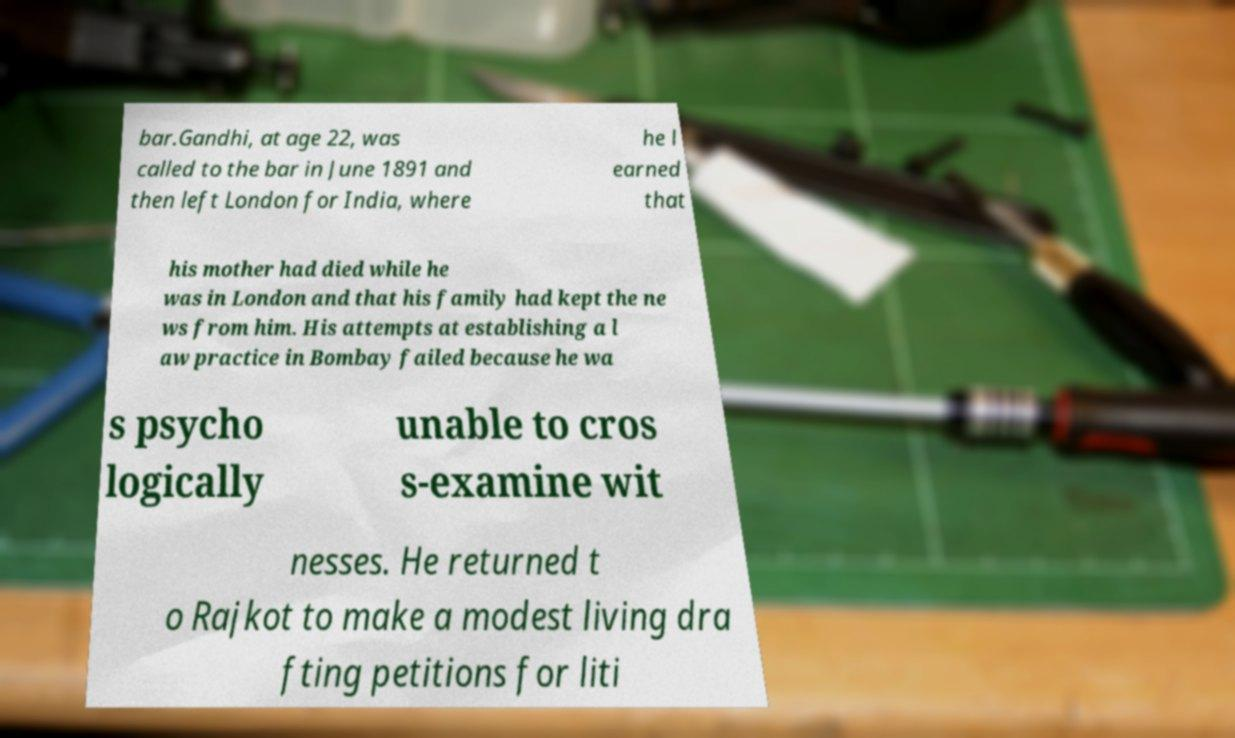Can you accurately transcribe the text from the provided image for me? bar.Gandhi, at age 22, was called to the bar in June 1891 and then left London for India, where he l earned that his mother had died while he was in London and that his family had kept the ne ws from him. His attempts at establishing a l aw practice in Bombay failed because he wa s psycho logically unable to cros s-examine wit nesses. He returned t o Rajkot to make a modest living dra fting petitions for liti 